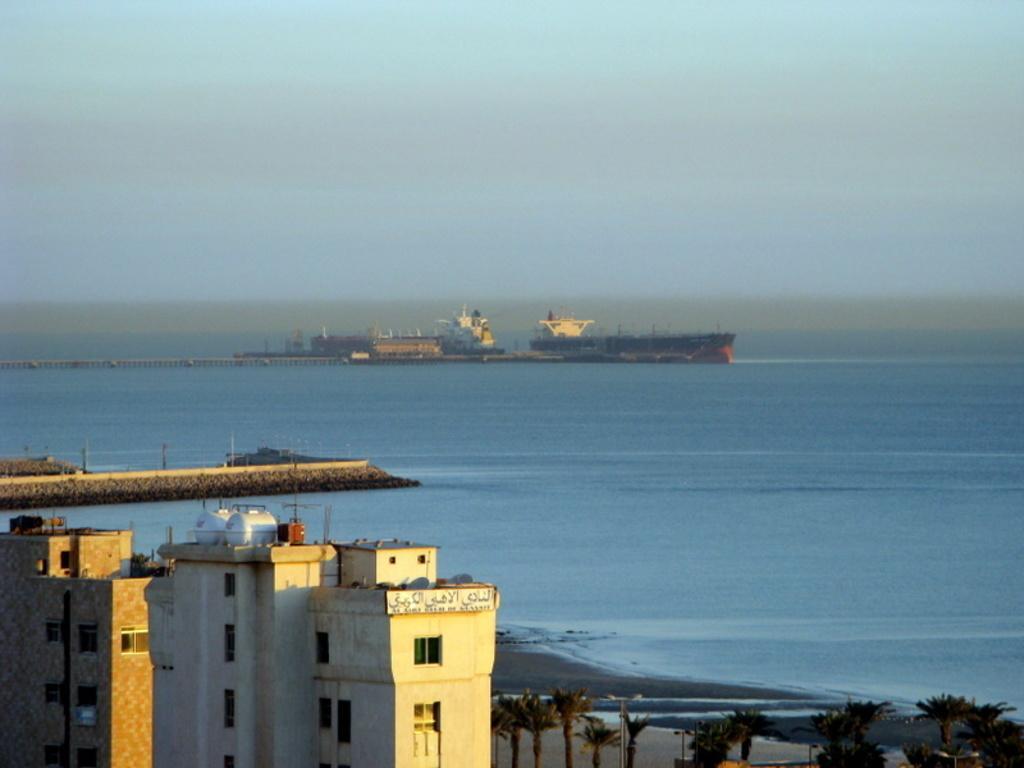Could you give a brief overview of what you see in this image? In this image in the front of there are buildings, trees. In the center there is water and in the background there are buildings. 